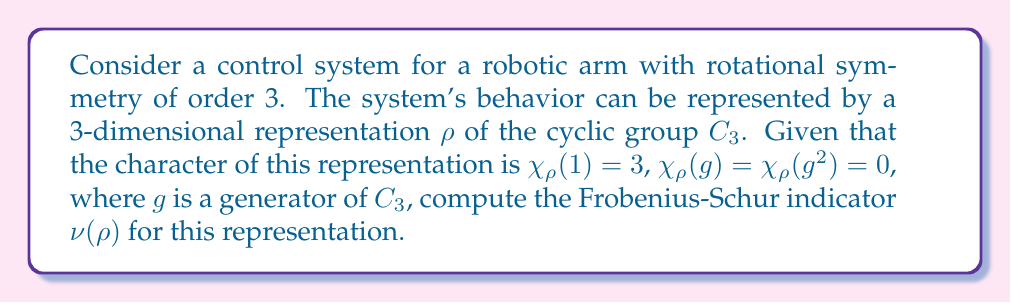What is the answer to this math problem? To compute the Frobenius-Schur indicator $\nu(\rho)$ for the given representation, we'll follow these steps:

1) The Frobenius-Schur indicator is defined as:

   $$\nu(\rho) = \frac{1}{|G|} \sum_{g \in G} \chi_\rho(g^2)$$

   where $|G|$ is the order of the group and $\chi_\rho$ is the character of the representation.

2) For the cyclic group $C_3$, we have $|G| = 3$ and the elements are $\{1, g, g^2\}$.

3) We need to calculate $\chi_\rho(g^2)$ for each element:
   - For the identity element: $\chi_\rho(1^2) = \chi_\rho(1) = 3$
   - For $g$: $\chi_\rho(g^2) = 0$ (given)
   - For $g^2$: $\chi_\rho((g^2)^2) = \chi_\rho(g^4) = \chi_\rho(g) = 0$ (since $g^4 = g$ in $C_3$)

4) Now we can compute the sum:

   $$\sum_{g \in G} \chi_\rho(g^2) = \chi_\rho(1^2) + \chi_\rho(g^2) + \chi_\rho((g^2)^2) = 3 + 0 + 0 = 3$$

5) Finally, we divide by $|G| = 3$:

   $$\nu(\rho) = \frac{1}{3} \cdot 3 = 1$$

Thus, the Frobenius-Schur indicator for this representation is 1.
Answer: $\nu(\rho) = 1$ 